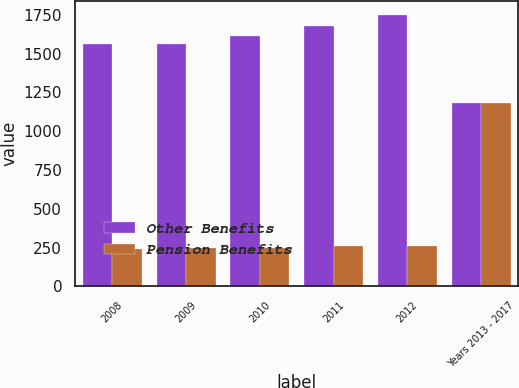<chart> <loc_0><loc_0><loc_500><loc_500><stacked_bar_chart><ecel><fcel>2008<fcel>2009<fcel>2010<fcel>2011<fcel>2012<fcel>Years 2013 - 2017<nl><fcel>Other Benefits<fcel>1560<fcel>1560<fcel>1610<fcel>1680<fcel>1750<fcel>1180<nl><fcel>Pension Benefits<fcel>240<fcel>250<fcel>250<fcel>260<fcel>260<fcel>1180<nl></chart> 